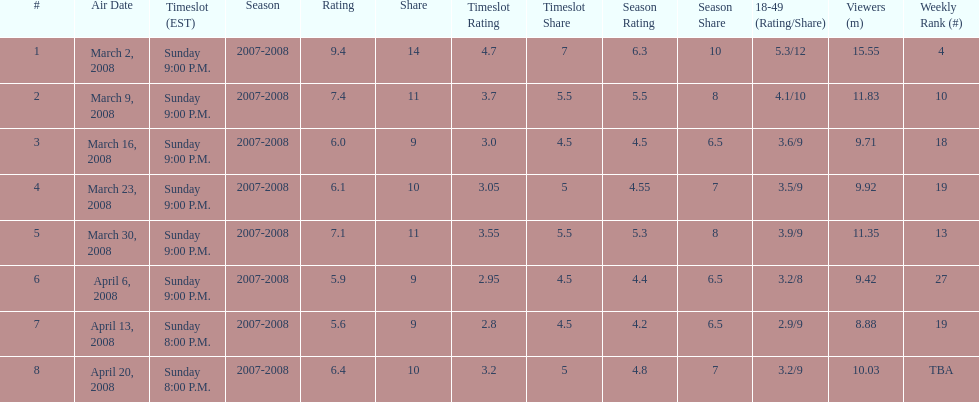What time slot did the show have for its first 6 episodes? Sunday 9:00 P.M. 